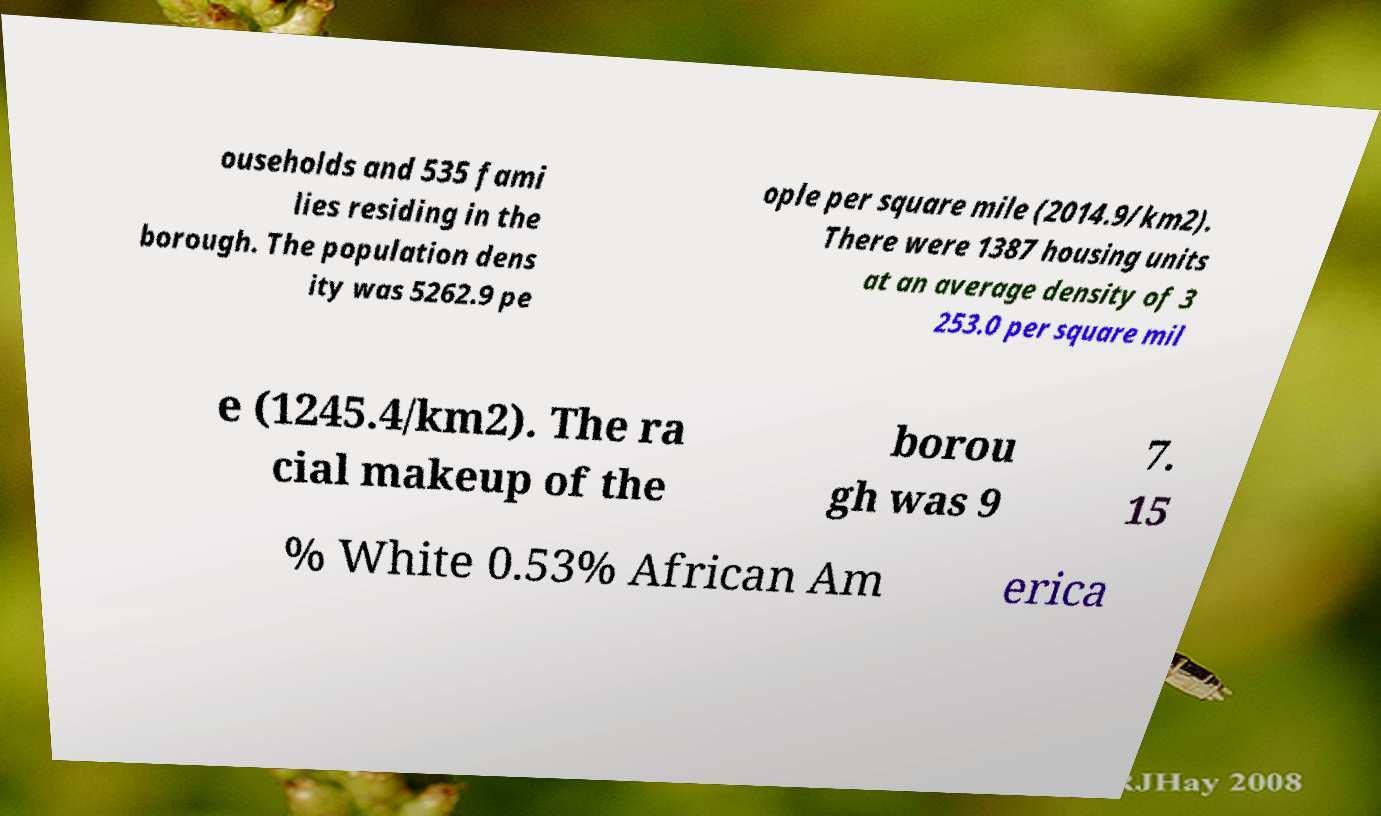What messages or text are displayed in this image? I need them in a readable, typed format. ouseholds and 535 fami lies residing in the borough. The population dens ity was 5262.9 pe ople per square mile (2014.9/km2). There were 1387 housing units at an average density of 3 253.0 per square mil e (1245.4/km2). The ra cial makeup of the borou gh was 9 7. 15 % White 0.53% African Am erica 